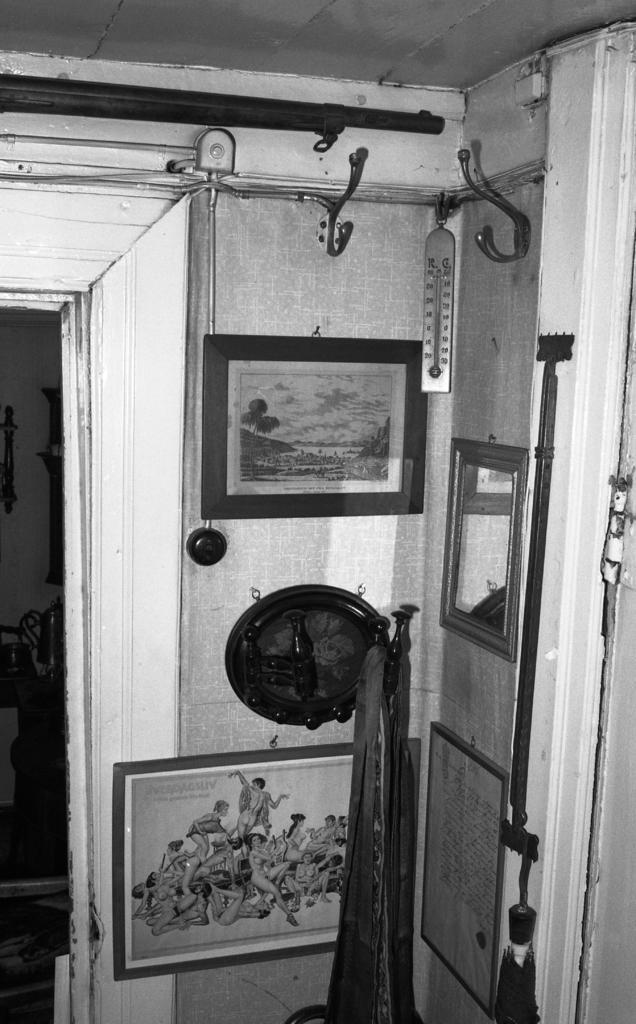What is the setting of the image? The image depicts the inside of a room. What can be seen on the walls of the room? There are paintings and other things on the walls. Can you describe any specific features of the room? There are metal rods visible in the image. How many eggs are visible on the boat in the image? There is no boat or eggs present in the image. 